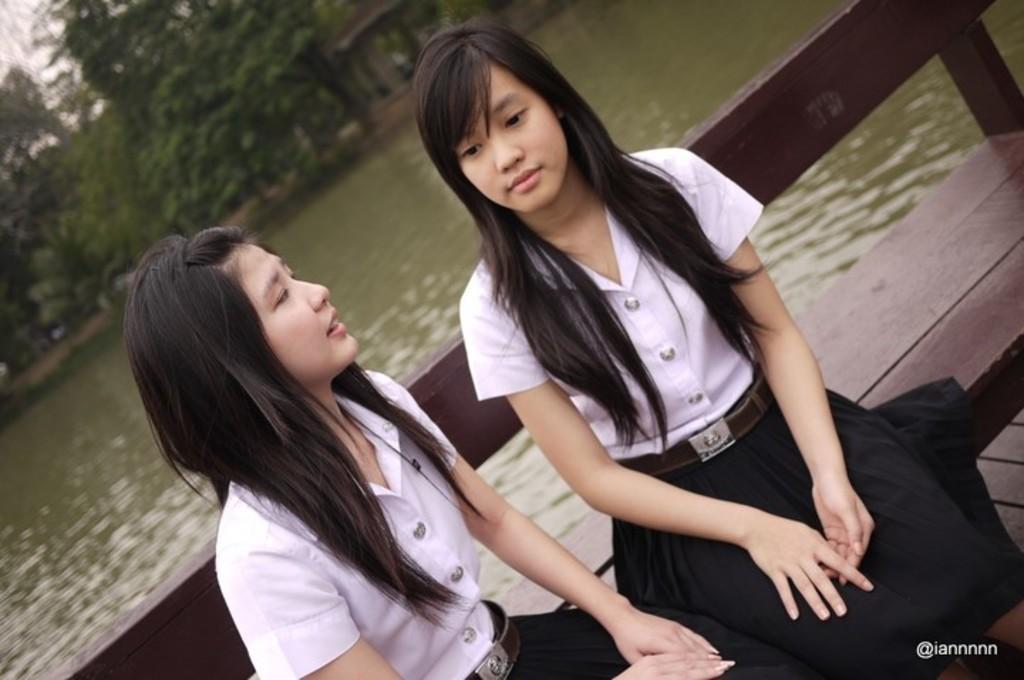How would you summarize this image in a sentence or two? In this picture we can see there are two women sitting on a bench. Behind the women there is the water, trees and the sky. On the image there is a watermark. 